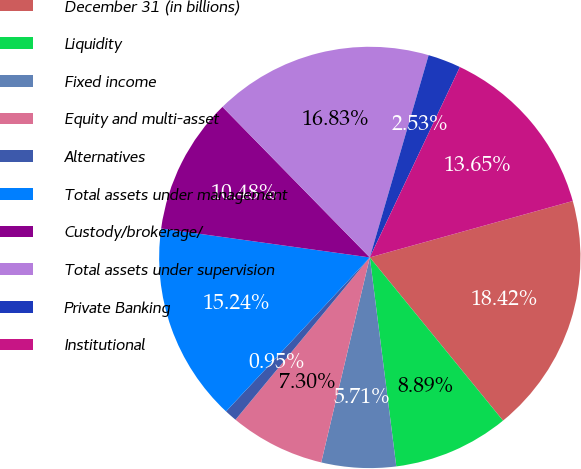<chart> <loc_0><loc_0><loc_500><loc_500><pie_chart><fcel>December 31 (in billions)<fcel>Liquidity<fcel>Fixed income<fcel>Equity and multi-asset<fcel>Alternatives<fcel>Total assets under management<fcel>Custody/brokerage/<fcel>Total assets under supervision<fcel>Private Banking<fcel>Institutional<nl><fcel>18.42%<fcel>8.89%<fcel>5.71%<fcel>7.3%<fcel>0.95%<fcel>15.24%<fcel>10.48%<fcel>16.83%<fcel>2.53%<fcel>13.65%<nl></chart> 